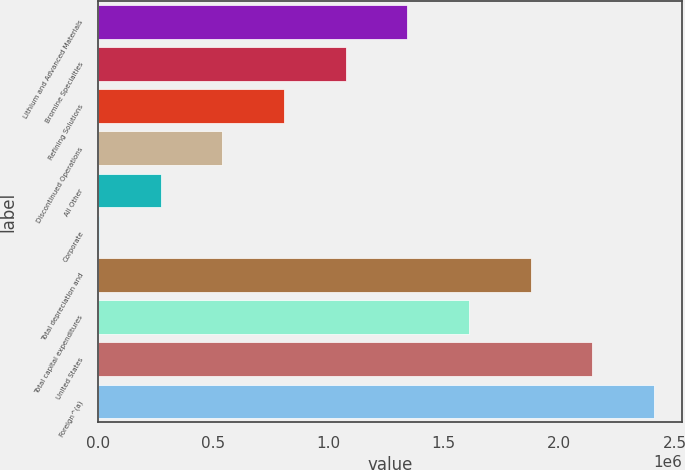Convert chart. <chart><loc_0><loc_0><loc_500><loc_500><bar_chart><fcel>Lithium and Advanced Materials<fcel>Bromine Specialties<fcel>Refining Solutions<fcel>Discontinued Operations<fcel>All Other<fcel>Corporate<fcel>Total depreciation and<fcel>Total capital expenditures<fcel>United States<fcel>Foreign^(a)<nl><fcel>1.34163e+06<fcel>1.07451e+06<fcel>807400<fcel>540285<fcel>273171<fcel>6056<fcel>1.87586e+06<fcel>1.60874e+06<fcel>2.14297e+06<fcel>2.41009e+06<nl></chart> 